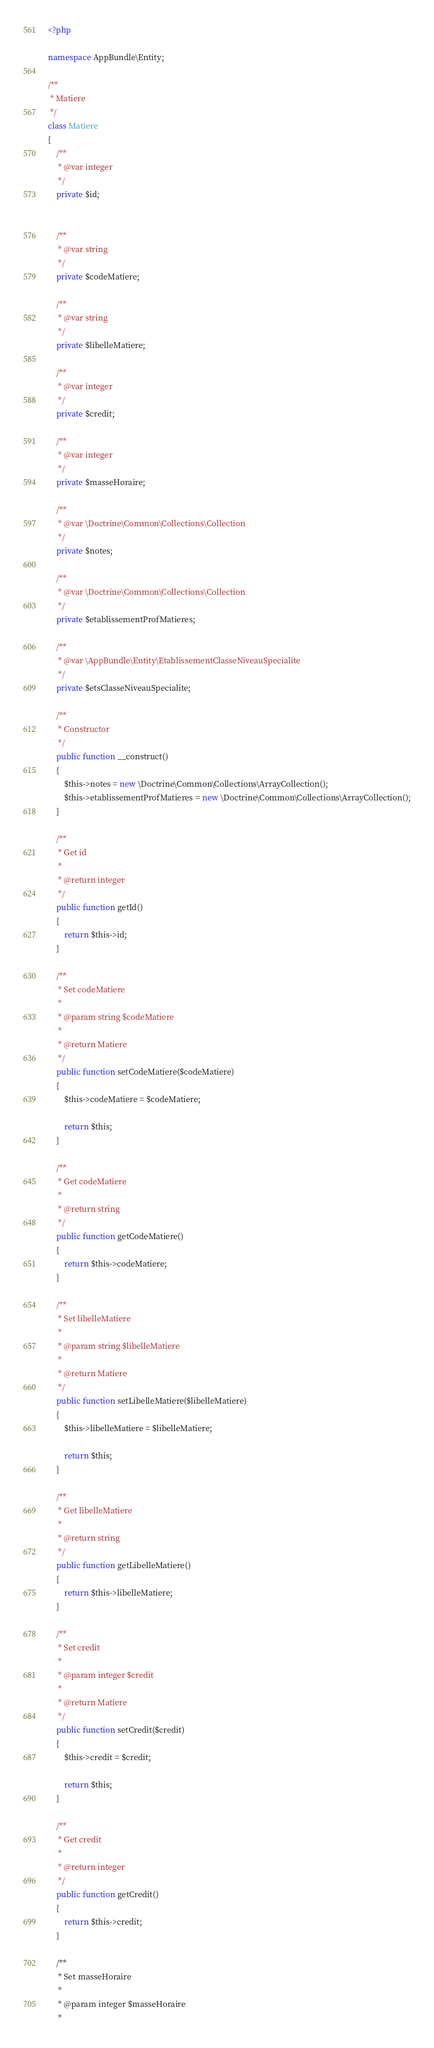Convert code to text. <code><loc_0><loc_0><loc_500><loc_500><_PHP_><?php

namespace AppBundle\Entity;

/**
 * Matiere
 */
class Matiere
{
    /**
     * @var integer
     */
    private $id;


    /**
     * @var string
     */
    private $codeMatiere;

    /**
     * @var string
     */
    private $libelleMatiere;

    /**
     * @var integer
     */
    private $credit;

    /**
     * @var integer
     */
    private $masseHoraire;

    /**
     * @var \Doctrine\Common\Collections\Collection
     */
    private $notes;

    /**
     * @var \Doctrine\Common\Collections\Collection
     */
    private $etablissementProfMatieres;

    /**
     * @var \AppBundle\Entity\EtablissementClasseNiveauSpecialite
     */
    private $etsClasseNiveauSpecialite;

    /**
     * Constructor
     */
    public function __construct()
    {
        $this->notes = new \Doctrine\Common\Collections\ArrayCollection();
        $this->etablissementProfMatieres = new \Doctrine\Common\Collections\ArrayCollection();
    }

    /**
     * Get id
     *
     * @return integer
     */
    public function getId()
    {
        return $this->id;
    }

    /**
     * Set codeMatiere
     *
     * @param string $codeMatiere
     *
     * @return Matiere
     */
    public function setCodeMatiere($codeMatiere)
    {
        $this->codeMatiere = $codeMatiere;

        return $this;
    }

    /**
     * Get codeMatiere
     *
     * @return string
     */
    public function getCodeMatiere()
    {
        return $this->codeMatiere;
    }

    /**
     * Set libelleMatiere
     *
     * @param string $libelleMatiere
     *
     * @return Matiere
     */
    public function setLibelleMatiere($libelleMatiere)
    {
        $this->libelleMatiere = $libelleMatiere;

        return $this;
    }

    /**
     * Get libelleMatiere
     *
     * @return string
     */
    public function getLibelleMatiere()
    {
        return $this->libelleMatiere;
    }

    /**
     * Set credit
     *
     * @param integer $credit
     *
     * @return Matiere
     */
    public function setCredit($credit)
    {
        $this->credit = $credit;

        return $this;
    }

    /**
     * Get credit
     *
     * @return integer
     */
    public function getCredit()
    {
        return $this->credit;
    }

    /**
     * Set masseHoraire
     *
     * @param integer $masseHoraire
     *</code> 